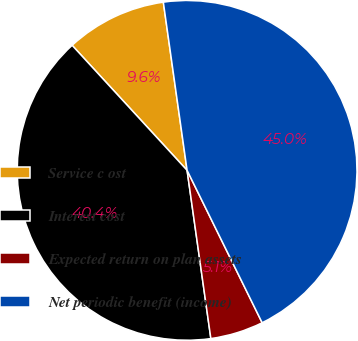Convert chart. <chart><loc_0><loc_0><loc_500><loc_500><pie_chart><fcel>Service c ost<fcel>Interest cost<fcel>Expected return on plan assets<fcel>Net periodic benefit (income)<nl><fcel>9.6%<fcel>40.4%<fcel>5.05%<fcel>44.95%<nl></chart> 